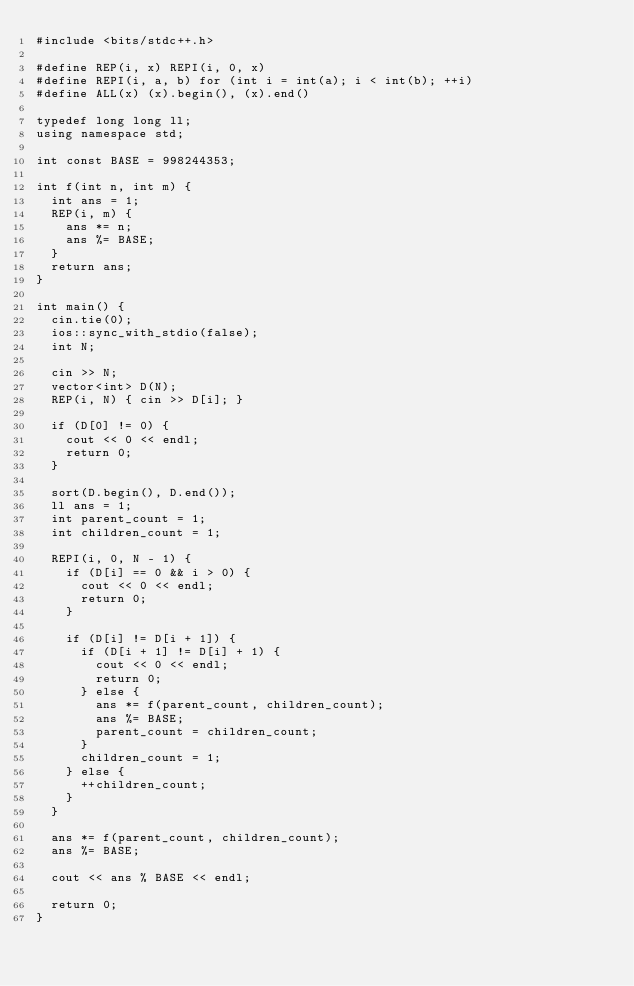<code> <loc_0><loc_0><loc_500><loc_500><_C++_>#include <bits/stdc++.h>

#define REP(i, x) REPI(i, 0, x)
#define REPI(i, a, b) for (int i = int(a); i < int(b); ++i)
#define ALL(x) (x).begin(), (x).end()

typedef long long ll;
using namespace std;

int const BASE = 998244353;

int f(int n, int m) {
  int ans = 1;
  REP(i, m) {
    ans *= n;
    ans %= BASE;
  }
  return ans;
}

int main() {
  cin.tie(0);
  ios::sync_with_stdio(false);
  int N;

  cin >> N;
  vector<int> D(N);
  REP(i, N) { cin >> D[i]; }

  if (D[0] != 0) {
    cout << 0 << endl;
    return 0;
  }

  sort(D.begin(), D.end());
  ll ans = 1;
  int parent_count = 1;
  int children_count = 1;

  REPI(i, 0, N - 1) {
    if (D[i] == 0 && i > 0) {
      cout << 0 << endl;
      return 0;
    }

    if (D[i] != D[i + 1]) {
      if (D[i + 1] != D[i] + 1) {
        cout << 0 << endl;
        return 0;
      } else {
        ans *= f(parent_count, children_count);
        ans %= BASE;
        parent_count = children_count;
      }
      children_count = 1;
    } else {
      ++children_count;
    }
  }

  ans *= f(parent_count, children_count);
  ans %= BASE;

  cout << ans % BASE << endl;

  return 0;
}
</code> 